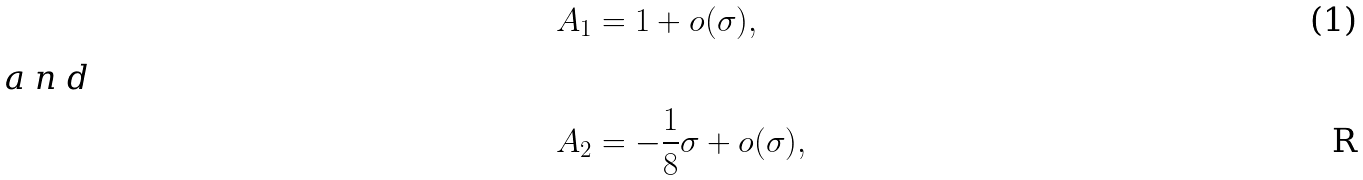Convert formula to latex. <formula><loc_0><loc_0><loc_500><loc_500>A _ { 1 } & = 1 + o ( \sigma ) , \intertext { a n d } A _ { 2 } & = - \frac { 1 } { 8 } \sigma + o ( \sigma ) ,</formula> 